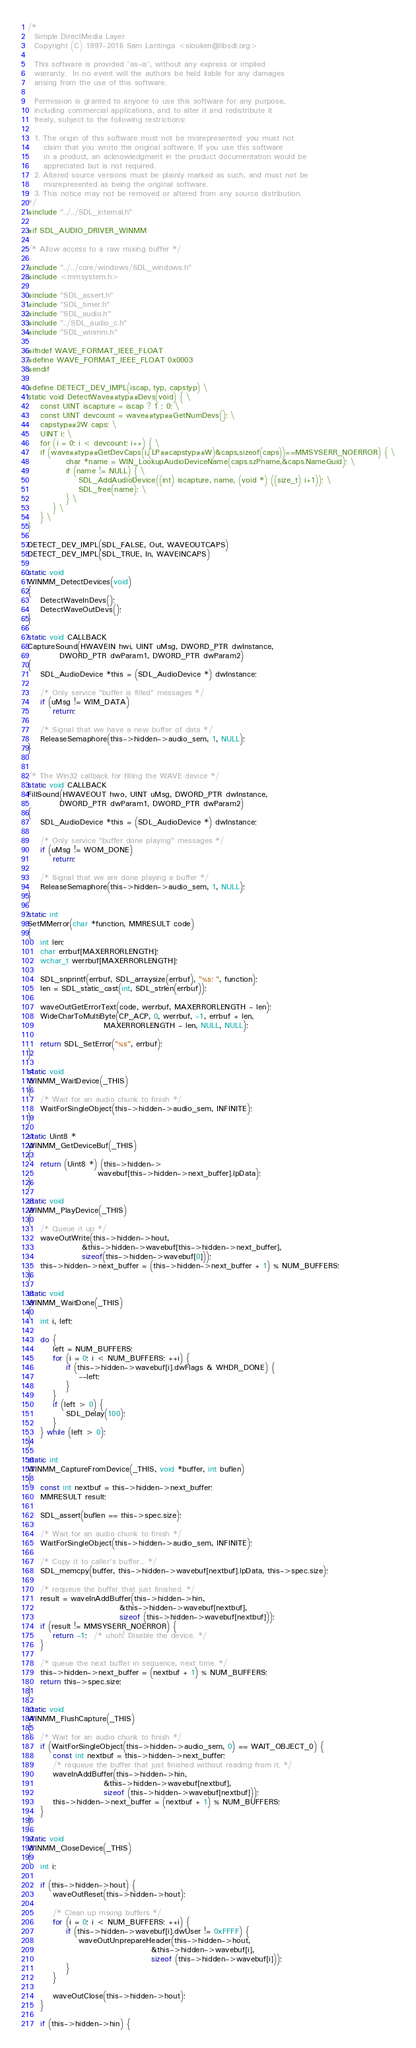Convert code to text. <code><loc_0><loc_0><loc_500><loc_500><_C_>/*
  Simple DirectMedia Layer
  Copyright (C) 1997-2016 Sam Lantinga <slouken@libsdl.org>

  This software is provided 'as-is', without any express or implied
  warranty.  In no event will the authors be held liable for any damages
  arising from the use of this software.

  Permission is granted to anyone to use this software for any purpose,
  including commercial applications, and to alter it and redistribute it
  freely, subject to the following restrictions:

  1. The origin of this software must not be misrepresented; you must not
     claim that you wrote the original software. If you use this software
     in a product, an acknowledgment in the product documentation would be
     appreciated but is not required.
  2. Altered source versions must be plainly marked as such, and must not be
     misrepresented as being the original software.
  3. This notice may not be removed or altered from any source distribution.
*/
#include "../../SDL_internal.h"

#if SDL_AUDIO_DRIVER_WINMM

/* Allow access to a raw mixing buffer */

#include "../../core/windows/SDL_windows.h"
#include <mmsystem.h>

#include "SDL_assert.h"
#include "SDL_timer.h"
#include "SDL_audio.h"
#include "../SDL_audio_c.h"
#include "SDL_winmm.h"

#ifndef WAVE_FORMAT_IEEE_FLOAT
#define WAVE_FORMAT_IEEE_FLOAT 0x0003
#endif

#define DETECT_DEV_IMPL(iscap, typ, capstyp) \
static void DetectWave##typ##Devs(void) { \
    const UINT iscapture = iscap ? 1 : 0; \
    const UINT devcount = wave##typ##GetNumDevs(); \
    capstyp##2W caps; \
    UINT i; \
    for (i = 0; i < devcount; i++) { \
	if (wave##typ##GetDevCaps(i,(LP##capstyp##W)&caps,sizeof(caps))==MMSYSERR_NOERROR) { \
            char *name = WIN_LookupAudioDeviceName(caps.szPname,&caps.NameGuid); \
            if (name != NULL) { \
                SDL_AddAudioDevice((int) iscapture, name, (void *) ((size_t) i+1)); \
                SDL_free(name); \
            } \
        } \
    } \
}

DETECT_DEV_IMPL(SDL_FALSE, Out, WAVEOUTCAPS)
DETECT_DEV_IMPL(SDL_TRUE, In, WAVEINCAPS)

static void
WINMM_DetectDevices(void)
{
    DetectWaveInDevs();
    DetectWaveOutDevs();
}

static void CALLBACK
CaptureSound(HWAVEIN hwi, UINT uMsg, DWORD_PTR dwInstance,
          DWORD_PTR dwParam1, DWORD_PTR dwParam2)
{
    SDL_AudioDevice *this = (SDL_AudioDevice *) dwInstance;

    /* Only service "buffer is filled" messages */
    if (uMsg != WIM_DATA)
        return;

    /* Signal that we have a new buffer of data */
    ReleaseSemaphore(this->hidden->audio_sem, 1, NULL);
}


/* The Win32 callback for filling the WAVE device */
static void CALLBACK
FillSound(HWAVEOUT hwo, UINT uMsg, DWORD_PTR dwInstance,
          DWORD_PTR dwParam1, DWORD_PTR dwParam2)
{
    SDL_AudioDevice *this = (SDL_AudioDevice *) dwInstance;

    /* Only service "buffer done playing" messages */
    if (uMsg != WOM_DONE)
        return;

    /* Signal that we are done playing a buffer */
    ReleaseSemaphore(this->hidden->audio_sem, 1, NULL);
}

static int
SetMMerror(char *function, MMRESULT code)
{
    int len;
    char errbuf[MAXERRORLENGTH];
    wchar_t werrbuf[MAXERRORLENGTH];

    SDL_snprintf(errbuf, SDL_arraysize(errbuf), "%s: ", function);
    len = SDL_static_cast(int, SDL_strlen(errbuf));

    waveOutGetErrorText(code, werrbuf, MAXERRORLENGTH - len);
    WideCharToMultiByte(CP_ACP, 0, werrbuf, -1, errbuf + len,
                        MAXERRORLENGTH - len, NULL, NULL);

    return SDL_SetError("%s", errbuf);
}

static void
WINMM_WaitDevice(_THIS)
{
    /* Wait for an audio chunk to finish */
    WaitForSingleObject(this->hidden->audio_sem, INFINITE);
}

static Uint8 *
WINMM_GetDeviceBuf(_THIS)
{
    return (Uint8 *) (this->hidden->
                      wavebuf[this->hidden->next_buffer].lpData);
}

static void
WINMM_PlayDevice(_THIS)
{
    /* Queue it up */
    waveOutWrite(this->hidden->hout,
                 &this->hidden->wavebuf[this->hidden->next_buffer],
                 sizeof(this->hidden->wavebuf[0]));
    this->hidden->next_buffer = (this->hidden->next_buffer + 1) % NUM_BUFFERS;
}

static void
WINMM_WaitDone(_THIS)
{
    int i, left;

    do {
        left = NUM_BUFFERS;
        for (i = 0; i < NUM_BUFFERS; ++i) {
            if (this->hidden->wavebuf[i].dwFlags & WHDR_DONE) {
                --left;
            }
        }
        if (left > 0) {
            SDL_Delay(100);
        }
    } while (left > 0);
}

static int
WINMM_CaptureFromDevice(_THIS, void *buffer, int buflen)
{
    const int nextbuf = this->hidden->next_buffer;
    MMRESULT result;

    SDL_assert(buflen == this->spec.size);

    /* Wait for an audio chunk to finish */
    WaitForSingleObject(this->hidden->audio_sem, INFINITE);

    /* Copy it to caller's buffer... */
    SDL_memcpy(buffer, this->hidden->wavebuf[nextbuf].lpData, this->spec.size);

    /* requeue the buffer that just finished. */
    result = waveInAddBuffer(this->hidden->hin,
                             &this->hidden->wavebuf[nextbuf],
                             sizeof (this->hidden->wavebuf[nextbuf]));
    if (result != MMSYSERR_NOERROR) {
        return -1;  /* uhoh! Disable the device. */
    }

    /* queue the next buffer in sequence, next time. */
    this->hidden->next_buffer = (nextbuf + 1) % NUM_BUFFERS;
    return this->spec.size;
}

static void
WINMM_FlushCapture(_THIS)
{
    /* Wait for an audio chunk to finish */
    if (WaitForSingleObject(this->hidden->audio_sem, 0) == WAIT_OBJECT_0) {
        const int nextbuf = this->hidden->next_buffer;
        /* requeue the buffer that just finished without reading from it. */
        waveInAddBuffer(this->hidden->hin,
                        &this->hidden->wavebuf[nextbuf],
                        sizeof (this->hidden->wavebuf[nextbuf]));
        this->hidden->next_buffer = (nextbuf + 1) % NUM_BUFFERS;
    }
}

static void
WINMM_CloseDevice(_THIS)
{
    int i;

    if (this->hidden->hout) {
        waveOutReset(this->hidden->hout);

        /* Clean up mixing buffers */
        for (i = 0; i < NUM_BUFFERS; ++i) {
            if (this->hidden->wavebuf[i].dwUser != 0xFFFF) {
                waveOutUnprepareHeader(this->hidden->hout,
                                       &this->hidden->wavebuf[i],
                                       sizeof (this->hidden->wavebuf[i]));
            }
        }

        waveOutClose(this->hidden->hout);
    }

    if (this->hidden->hin) {</code> 